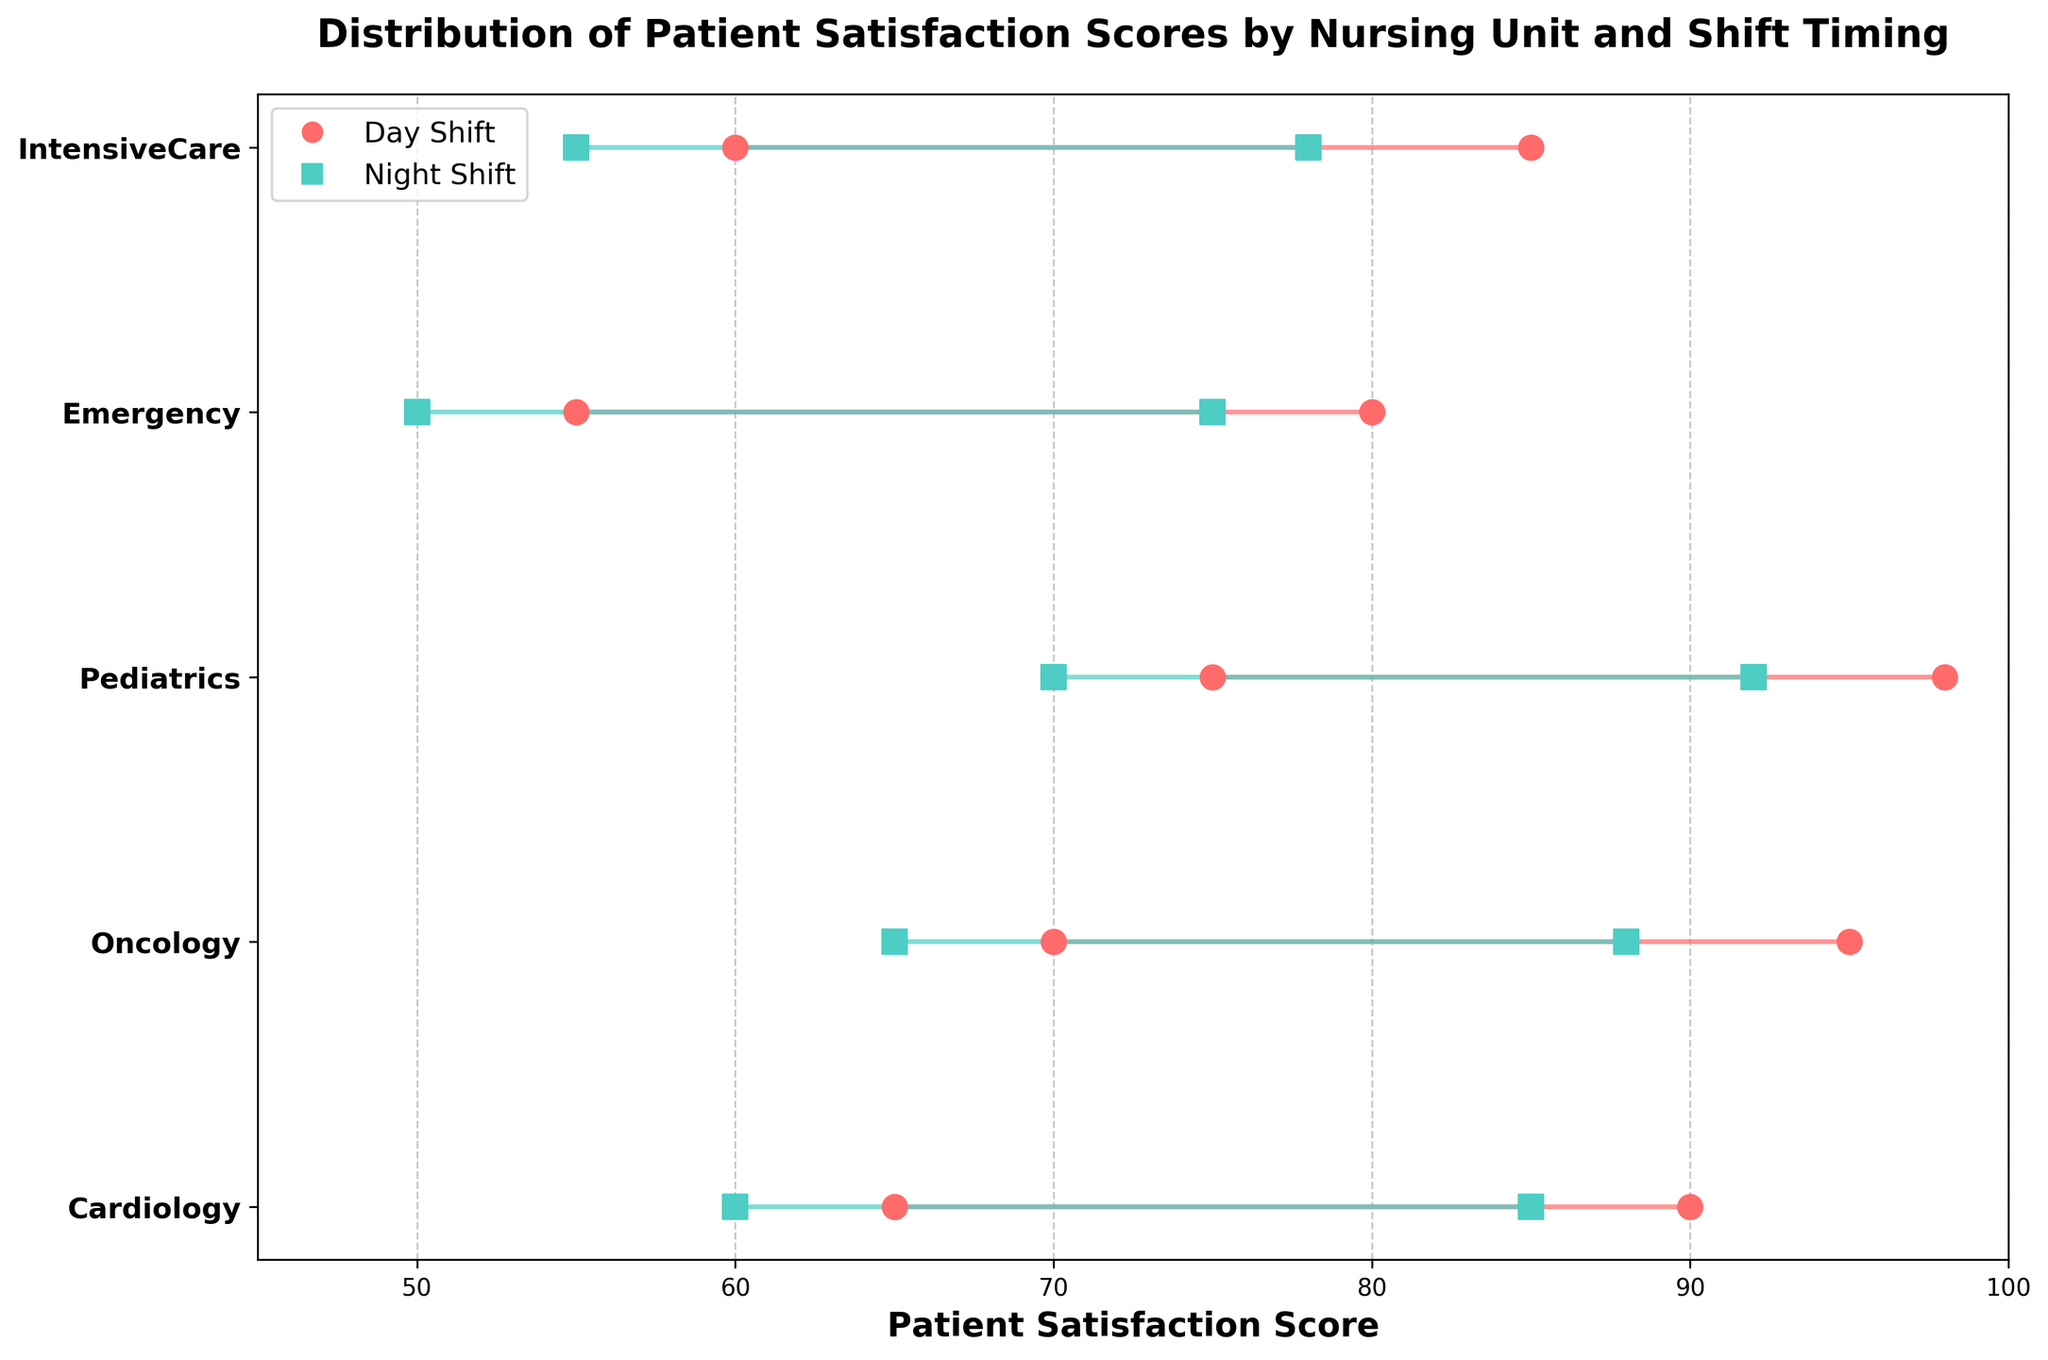What's the title of the figure? The title of the figure is usually displayed at the top. It summarizes what the data visualization is about, helping the viewer understand the context. In this case, the title indicates that the plot shows the distribution of patient satisfaction scores by nursing unit and shift timing.
Answer: Distribution of Patient Satisfaction Scores by Nursing Unit and Shift Timing Which nursing unit has the highest maximum patient satisfaction score during the day shift? To determine this, look at the maximum patient satisfaction scores for each nursing unit during the day shift. Compare these values to find the highest one. Pediatrics has the highest maximum score.
Answer: Pediatrics What is the range of patient satisfaction scores for the Emergency unit during the night shift? The range can be calculated by subtracting the minimum satisfaction score from the maximum satisfaction score for the Emergency unit during the night shift. The data for Emergency (night shift) is 50 to 75, so the range is 75 - 50.
Answer: 25 Which shift, day or night, generally has higher patient satisfaction scores for the Oncology unit? Compare the ranges of patient satisfaction scores for the Oncology unit during the day and night shifts. The Oncology unit has a score range of 70 to 95 for the day shift and 65 to 88 for the night shift. Generally, the day shift has higher scores.
Answer: Day How does the patient satisfaction score range for the Cardiology unit during the day shift compare to the night shift? Compare the range of patient satisfaction scores for the day shift (65 to 90) to the night shift (60 to 85). By subtracting the minimum from the maximum, we get 90 - 65 = 25 for the day shift and 85 - 60 = 25 for the night shift.
Answer: They have the same range of 25 What is the average of the maximum patient satisfaction scores for the day shifts across all units? List out the maximum patient satisfaction scores for each unit during the day shift: 90 (Cardiology), 95 (Oncology), 98 (Pediatrics), 80 (Emergency), 85 (IntensiveCare). Sum these values and then divide by the number of units: (90 + 95 + 98 + 80 + 85) / 5. The sum is 448, and the average is 448 / 5.
Answer: 89.6 Which nursing unit has the smallest difference between the maximum patient satisfaction scores for day and night shifts? For each nursing unit, compute the difference between the maximum day shift score and the maximum night shift score and then compare these differences. For Pediatrics, it’s 98-92=6, for other units it is greater. Therefore, Pediatrics has the smallest difference.
Answer: Pediatrics What is the total number of unique nursing units displayed in the figure? Count the number of unique nursing units listed on the y-axis of the figure. The units are Cardiology, Oncology, Pediatrics, Emergency, and IntensiveCare, giving us 5 unique units.
Answer: 5 How does the satisfaction score range for the IntensiveCare unit during day shifts compare to Oncology during night shifts? Calculate the range as the maximum minus the minimum for both units and shifts. For IntensiveCare (day shift), the range is 85 - 60 = 25. For Oncology (night shift), it is 88 - 65 = 23. Compare these values to see that the IntensiveCare day shift has a slightly larger range.
Answer: IntensiveCare's range is larger 